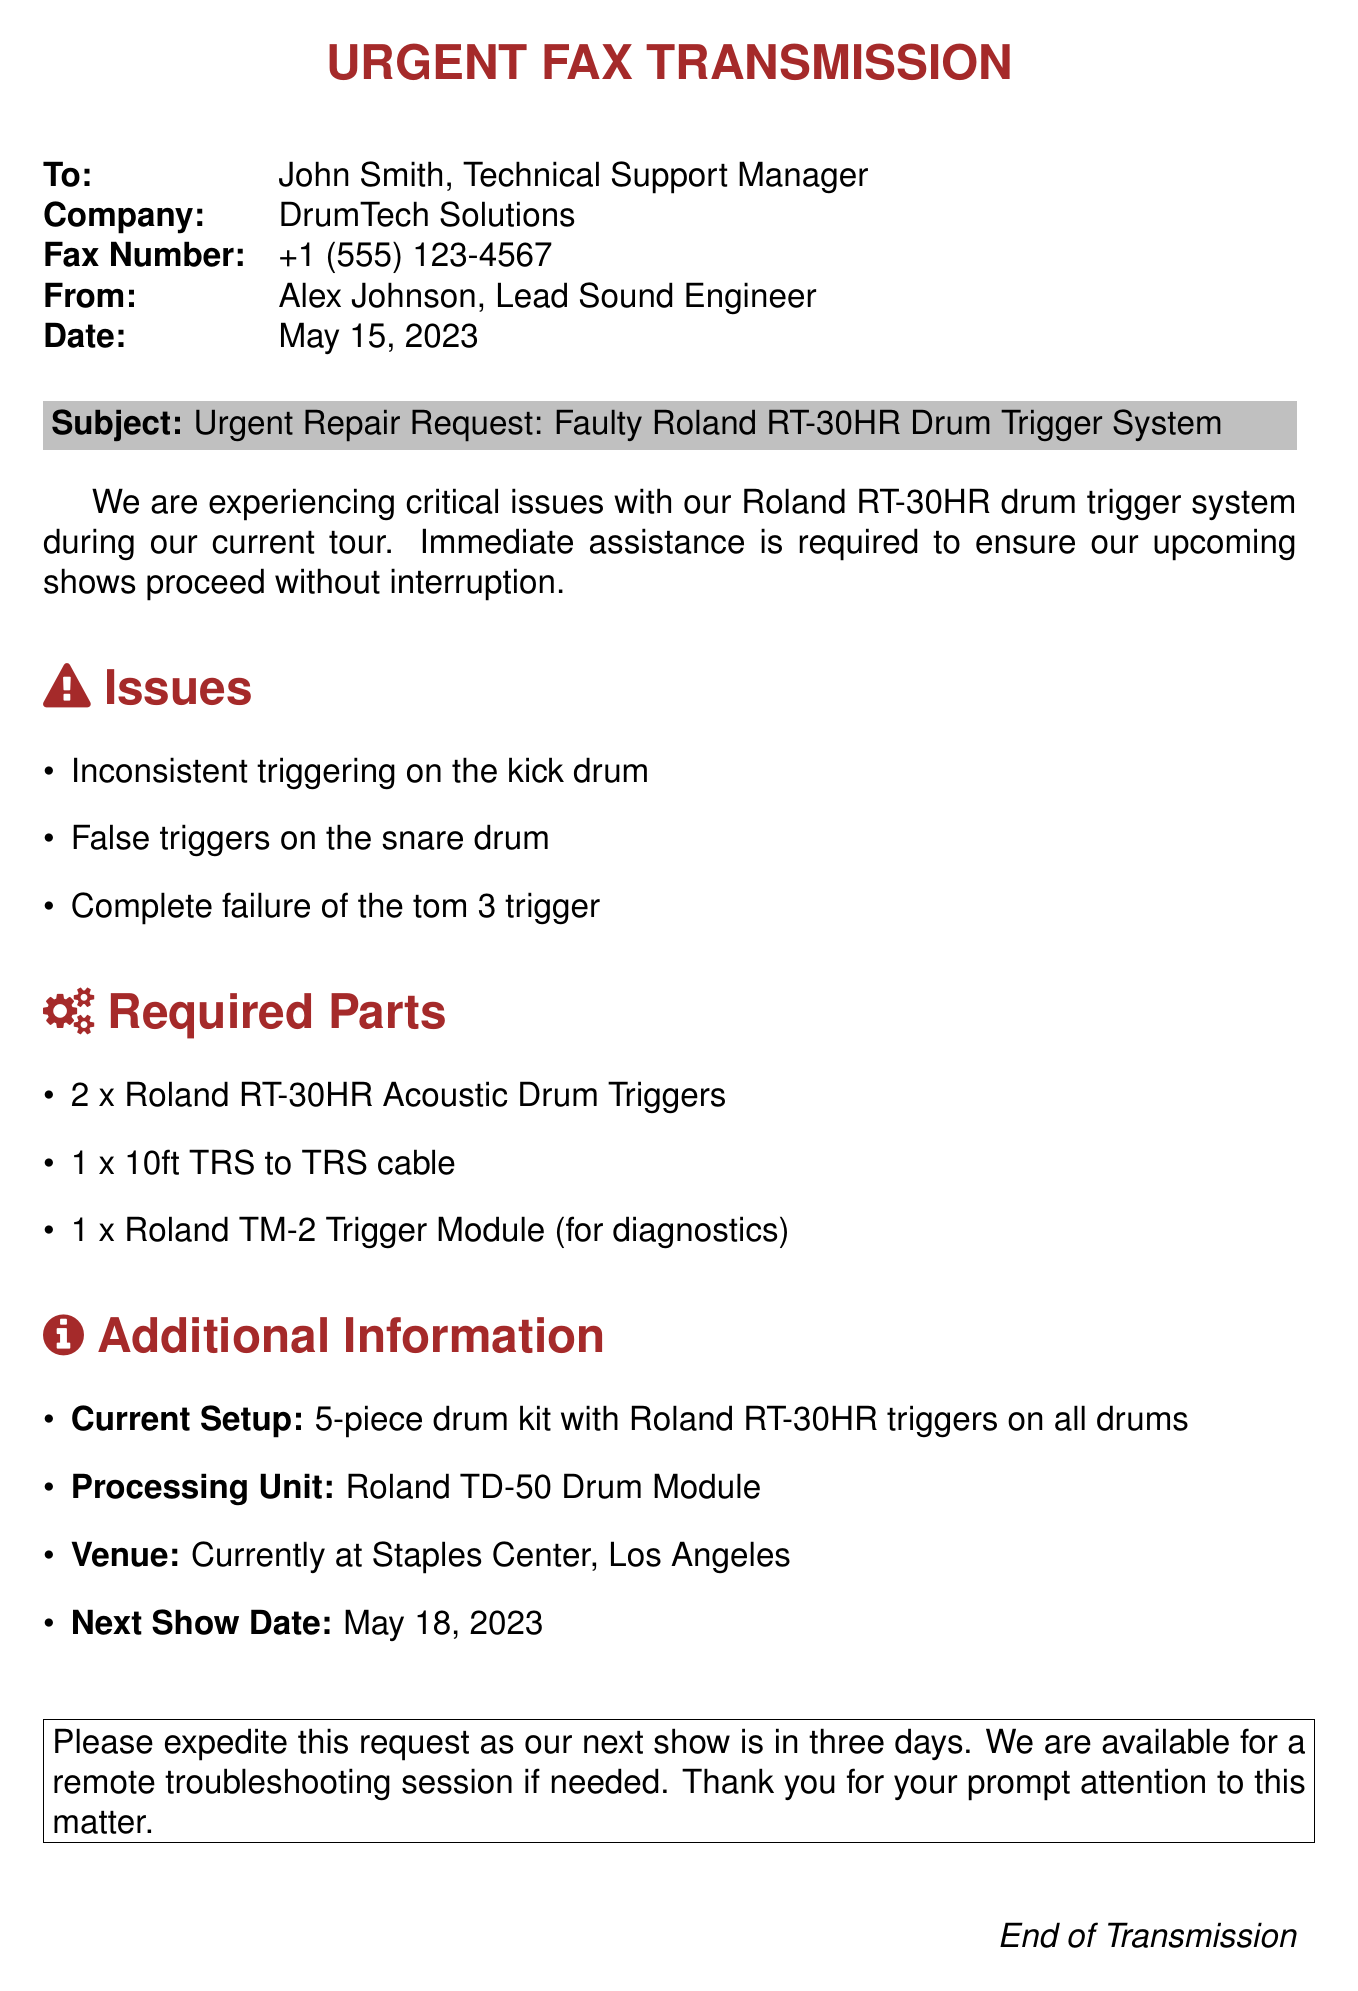what is the subject of the fax? The subject is specified in the document as "Urgent Repair Request: Faulty Roland RT-30HR Drum Trigger System."
Answer: Urgent Repair Request: Faulty Roland RT-30HR Drum Trigger System who is the recipient of this fax? The recipient's name is mentioned at the beginning of the document.
Answer: John Smith what is the date of the fax? The date is listed clearly in the header of the document.
Answer: May 15, 2023 how many drum triggers are being requested? The required parts section lists the quantity of triggers needed.
Answer: 2 what is the issue with the tom 3 trigger? The document explicitly mentions the failure of a specific trigger in the issues section.
Answer: Complete failure where is the current venue located? The venue is mentioned in the additional information section of the document.
Answer: Staples Center, Los Angeles when is the next show date? The next show date is provided in the additional information section.
Answer: May 18, 2023 what processing unit is being used? The processing unit is detailed in the additional information section of the document.
Answer: Roland TD-50 Drum Module what kind of cable is requested? The required parts section specifies the type of cable needed for the repair.
Answer: 10ft TRS to TRS cable 